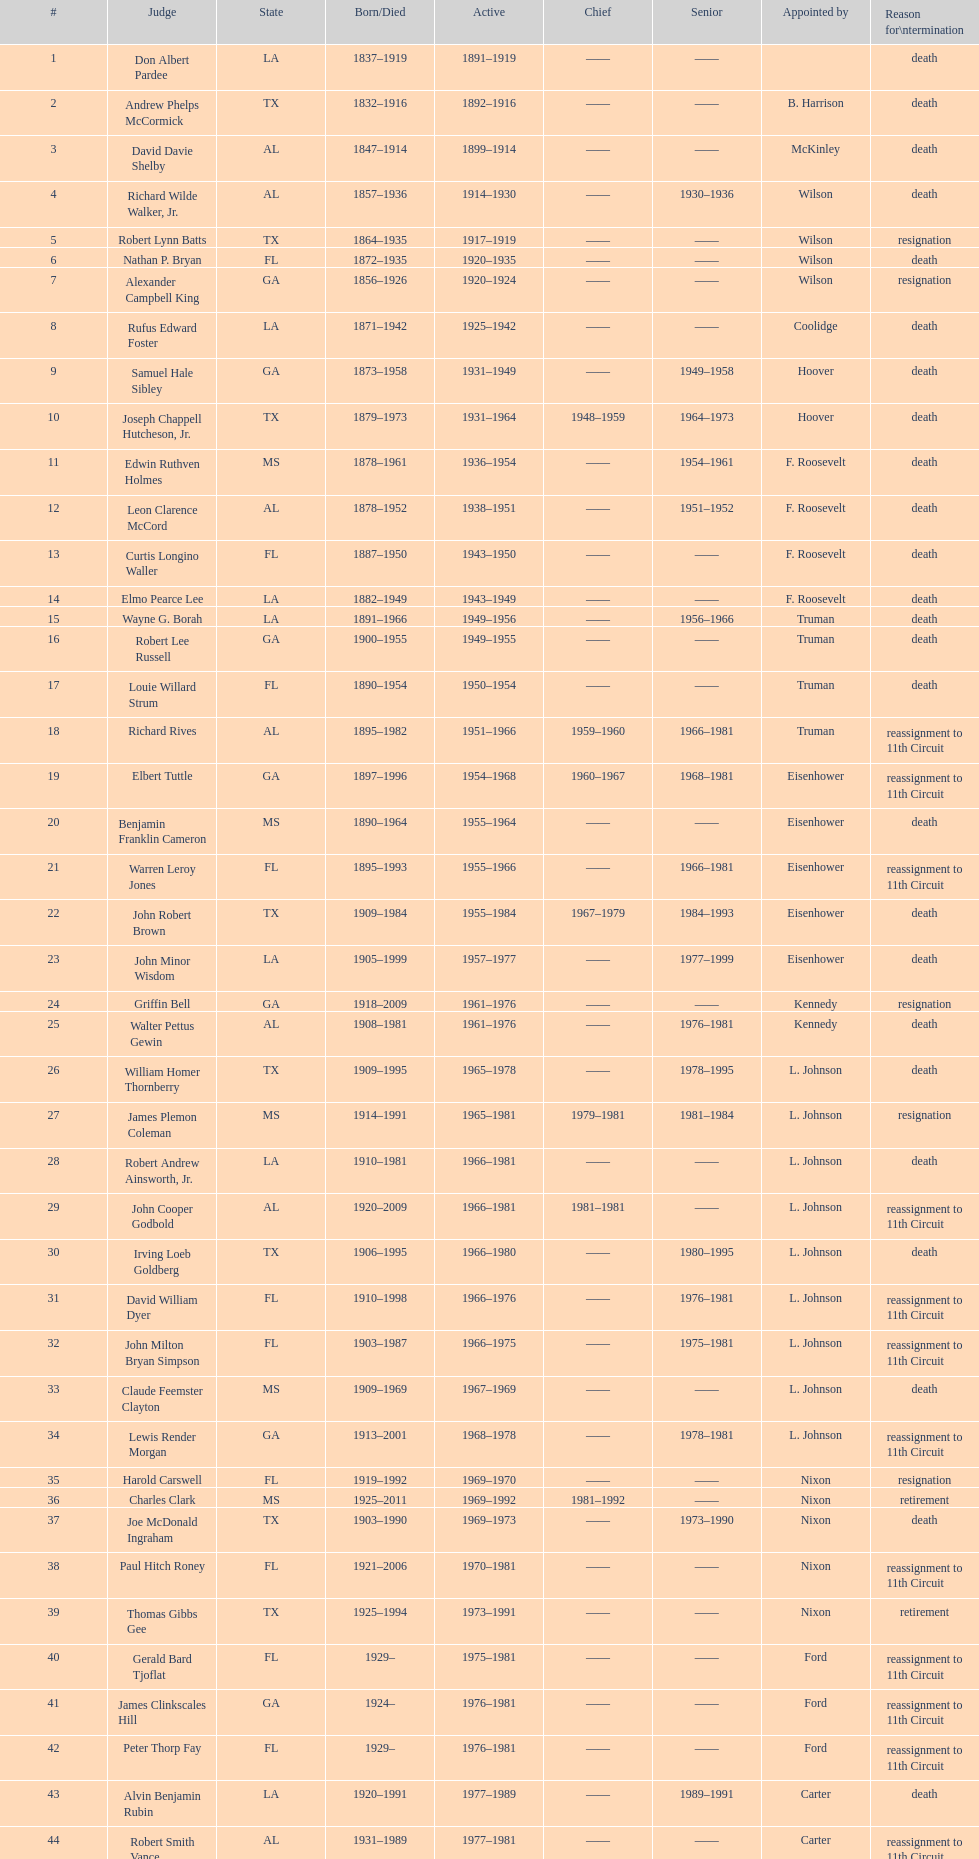How many judges were selected by president carter? 13. 